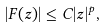<formula> <loc_0><loc_0><loc_500><loc_500>| F ( z ) | \leq C | z | ^ { p } ,</formula> 